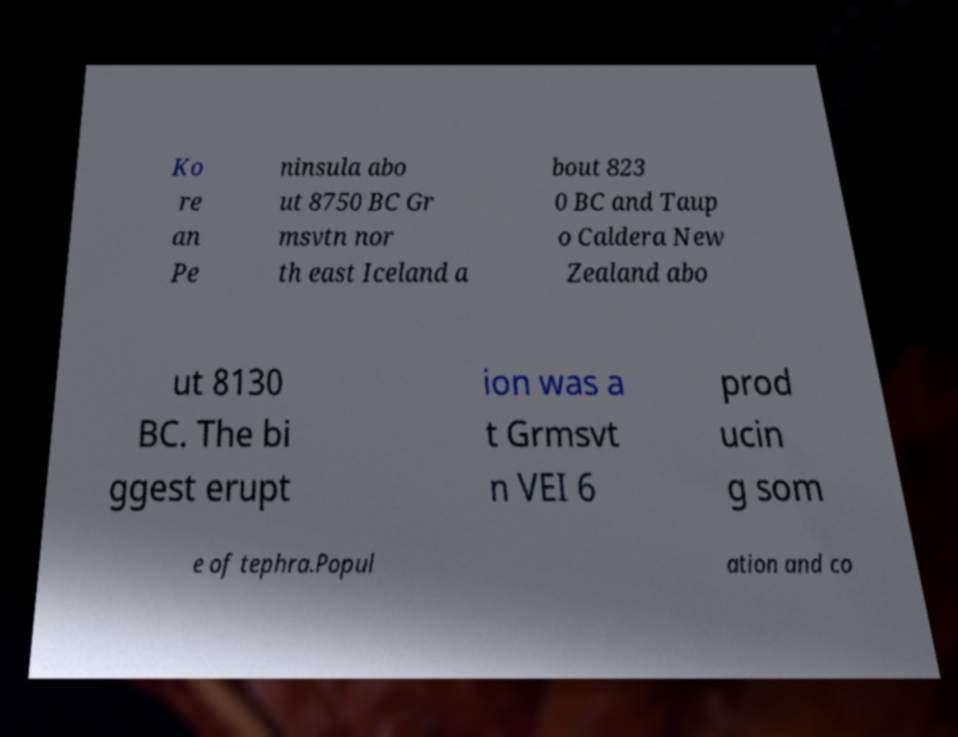Can you read and provide the text displayed in the image?This photo seems to have some interesting text. Can you extract and type it out for me? Ko re an Pe ninsula abo ut 8750 BC Gr msvtn nor th east Iceland a bout 823 0 BC and Taup o Caldera New Zealand abo ut 8130 BC. The bi ggest erupt ion was a t Grmsvt n VEI 6 prod ucin g som e of tephra.Popul ation and co 